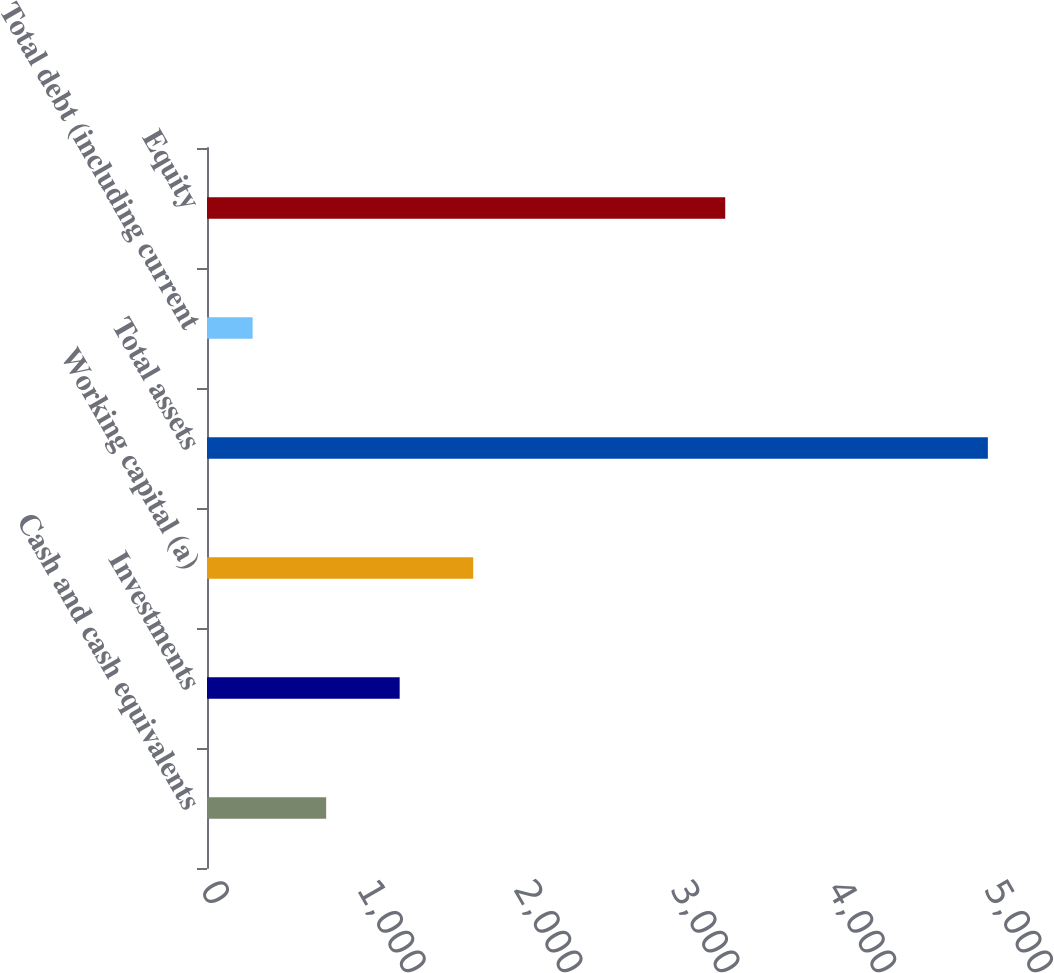<chart> <loc_0><loc_0><loc_500><loc_500><bar_chart><fcel>Cash and cash equivalents<fcel>Investments<fcel>Working capital (a)<fcel>Total assets<fcel>Total debt (including current<fcel>Equity<nl><fcel>759.9<fcel>1228.8<fcel>1697.7<fcel>4980<fcel>291<fcel>3305<nl></chart> 